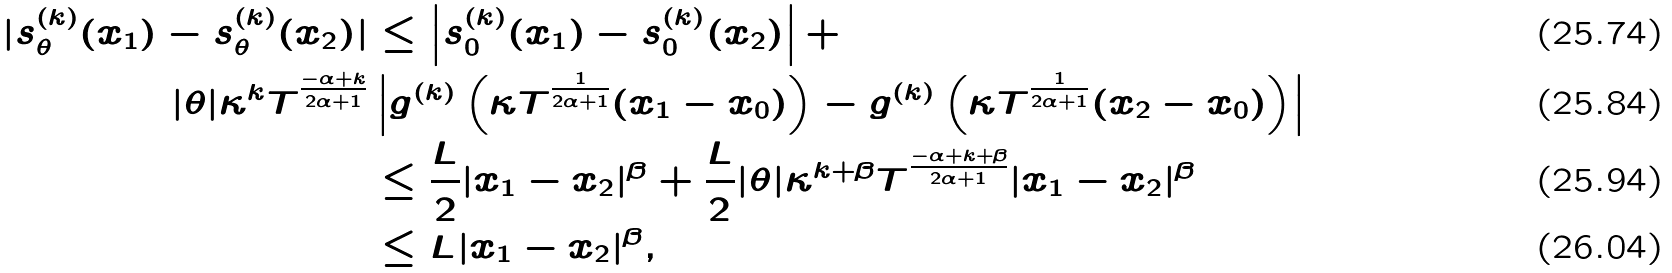Convert formula to latex. <formula><loc_0><loc_0><loc_500><loc_500>| s ^ { ( k ) } _ { \theta } ( x _ { 1 } ) - s ^ { ( k ) } _ { \theta } ( x _ { 2 } ) | & \leq \left | s ^ { ( k ) } _ { 0 } ( x _ { 1 } ) - s ^ { ( k ) } _ { 0 } ( x _ { 2 } ) \right | + \\ | \theta | \kappa ^ { k } T ^ { \frac { - \alpha + k } { 2 \alpha + 1 } } & \left | g ^ { ( k ) } \left ( \kappa T ^ { \frac { 1 } { 2 \alpha + 1 } } ( x _ { 1 } - x _ { 0 } ) \right ) - g ^ { ( k ) } \left ( \kappa T ^ { \frac { 1 } { 2 \alpha + 1 } } ( x _ { 2 } - x _ { 0 } ) \right ) \right | \\ & \leq \frac { L } { 2 } | x _ { 1 } - x _ { 2 } | ^ { \beta } + \frac { L } { 2 } | \theta | \kappa ^ { k + \beta } T ^ { \frac { - \alpha + k + \beta } { 2 \alpha + 1 } } | x _ { 1 } - x _ { 2 } | ^ { \beta } \\ & \leq L | x _ { 1 } - x _ { 2 } | ^ { \beta } ,</formula> 